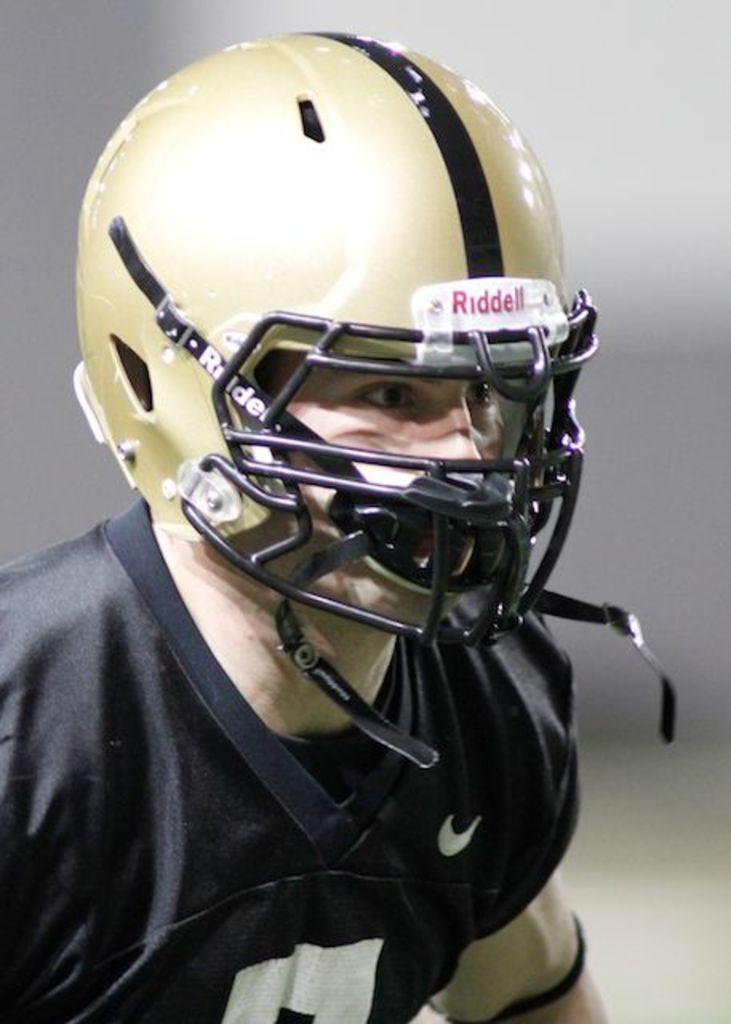Who or what is present in the image? There is a person in the image. What is the person wearing on their head? The person is wearing a helmet. What color is the t-shirt the person is wearing? The person is wearing a black color t-shirt. What type of trousers is the person wearing in the image? The provided facts do not mention any trousers, so we cannot determine the type of trousers the person is wearing in the image. 